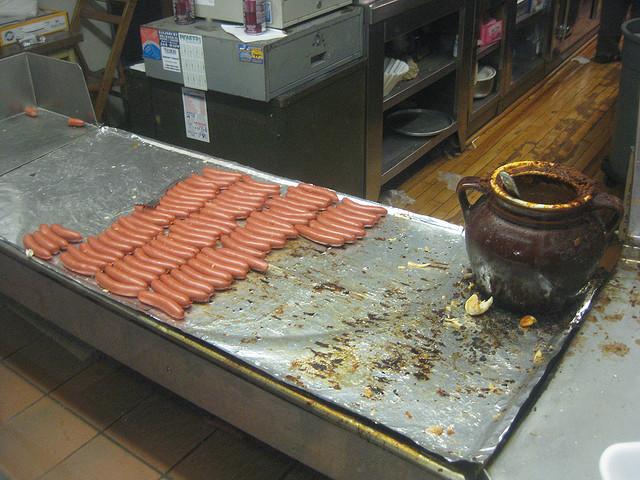Are the hot dogs ready to eat?
Give a very brief answer. Yes. What are the hot dogs cooking on?
Answer briefly. Grill. Does this place appear to be a restaurant?
Answer briefly. Yes. If each person is eating two hot dogs, how many people will be eating?
Write a very short answer. 38. What are been cooked?
Be succinct. Hot dogs. How many columns of hot dogs are lined up on the grill?
Answer briefly. 5. Is there any meat?
Write a very short answer. Yes. 